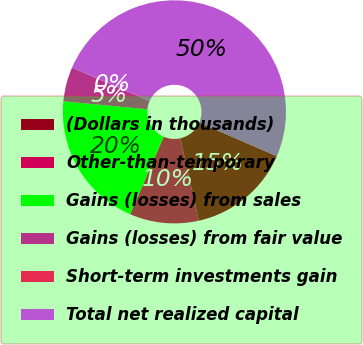<chart> <loc_0><loc_0><loc_500><loc_500><pie_chart><fcel>(Dollars in thousands)<fcel>Other-than-temporary<fcel>Gains (losses) from sales<fcel>Gains (losses) from fair value<fcel>Short-term investments gain<fcel>Total net realized capital<nl><fcel>15.0%<fcel>10.0%<fcel>20.0%<fcel>5.0%<fcel>0.0%<fcel>50.0%<nl></chart> 